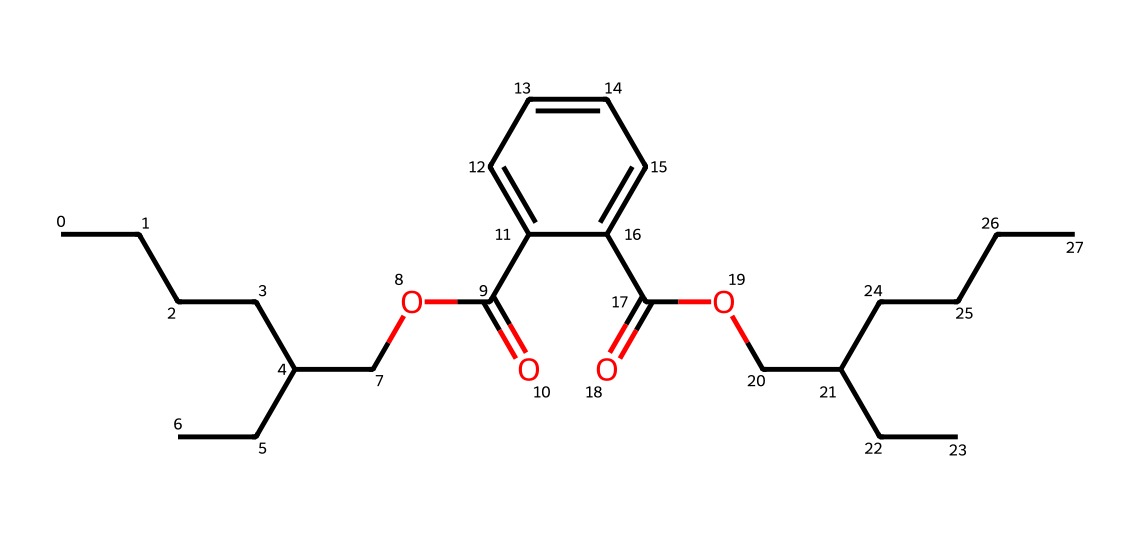How many carbon atoms are in this molecule? The SMILES representation can be analyzed to count the carbon atoms. This structure has multiple carbon chains and rings. By scanning through the SMILES notation, there are 22 carbon atoms in total.
Answer: 22 What is the function of the ester group in this molecule? The ester group, often represented by -COO-, is commonly found in esters which are formed by reactions between alcohol and acid. In this compound, it contributes to the flexibility and properties of the polymer, making it suitable for use in children's clothing.
Answer: flexibility How many functional groups are present in the molecule? By analyzing the SMILES structure, we can identify the functional groups: there are ester groups (two), carboxylic acid groups (two), and ether groups (one). This totals to five functional groups recognized within the molecular structure.
Answer: five What type of polymer is formed from this compound? This compound is a phthalate ester, which is commonly used as a plasticizer in various polymers to improve their flexibility and workability, especially in children's clothing.
Answer: phthalate ester Which part of the molecule is likely responsible for its plasticizing properties? The long carbon chains and ester groups within the structure work together to lower the glass transition temperature, thereby increasing flexibility and plasticity in the material, making them suitable for use in children's clothing.
Answer: ester groups 